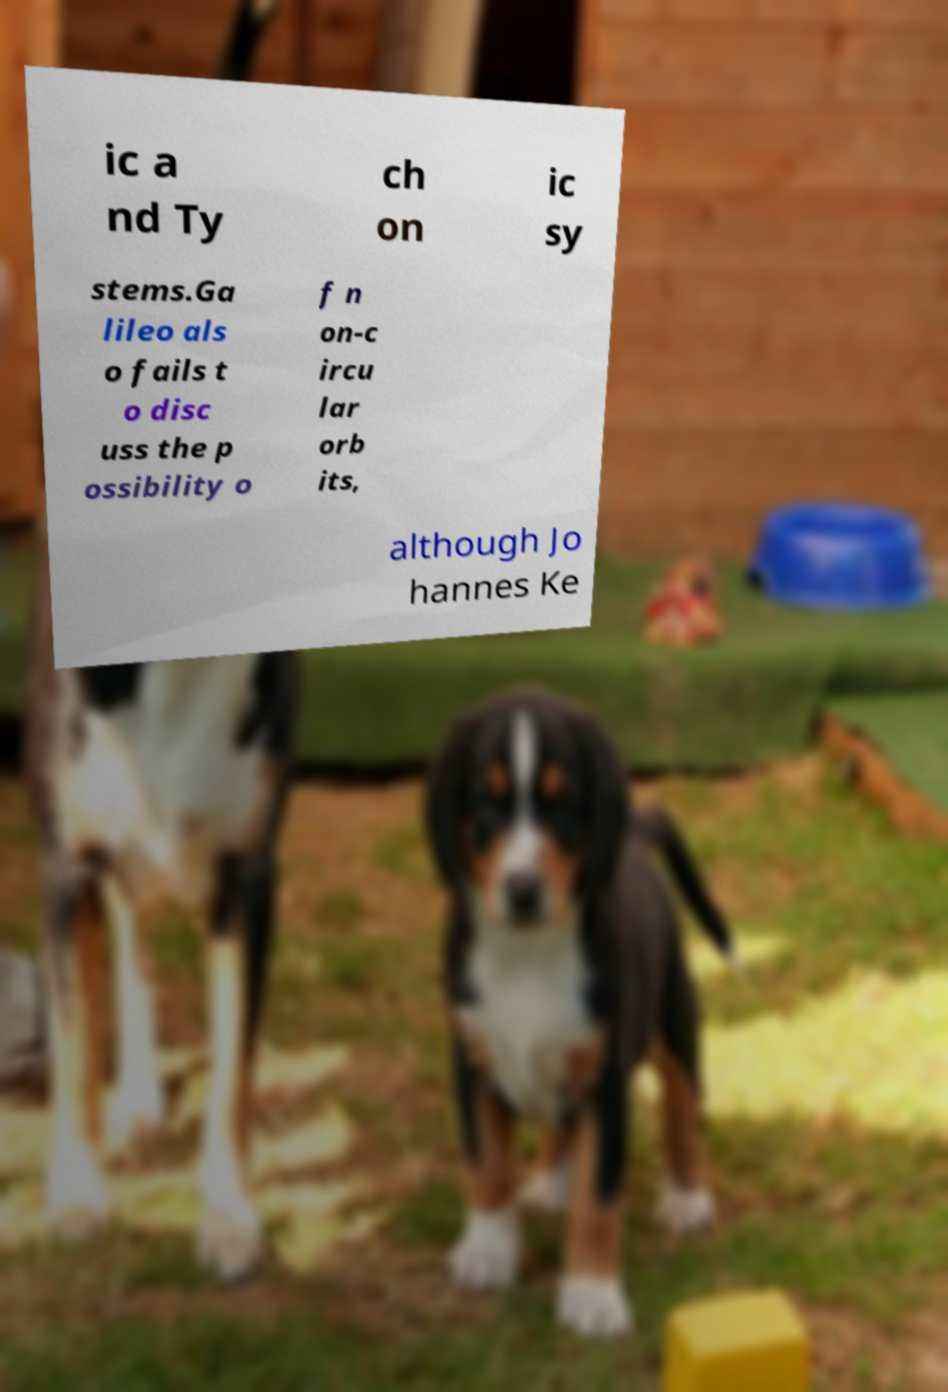Please read and relay the text visible in this image. What does it say? ic a nd Ty ch on ic sy stems.Ga lileo als o fails t o disc uss the p ossibility o f n on-c ircu lar orb its, although Jo hannes Ke 